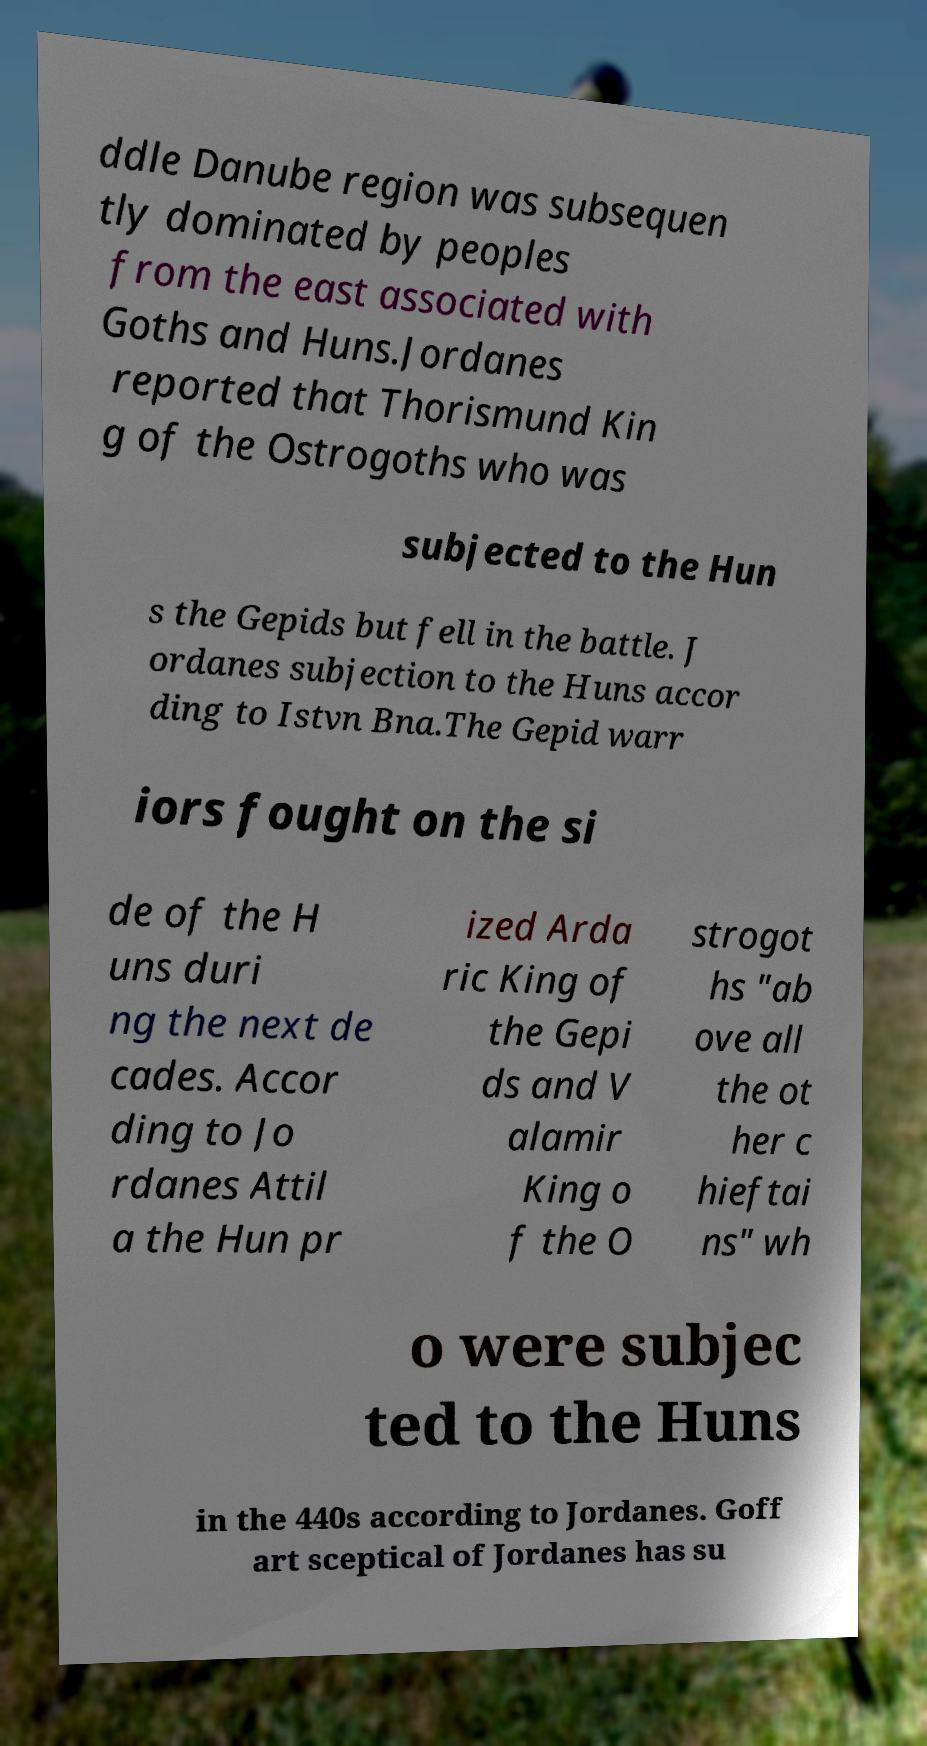Please read and relay the text visible in this image. What does it say? ddle Danube region was subsequen tly dominated by peoples from the east associated with Goths and Huns.Jordanes reported that Thorismund Kin g of the Ostrogoths who was subjected to the Hun s the Gepids but fell in the battle. J ordanes subjection to the Huns accor ding to Istvn Bna.The Gepid warr iors fought on the si de of the H uns duri ng the next de cades. Accor ding to Jo rdanes Attil a the Hun pr ized Arda ric King of the Gepi ds and V alamir King o f the O strogot hs "ab ove all the ot her c hieftai ns" wh o were subjec ted to the Huns in the 440s according to Jordanes. Goff art sceptical of Jordanes has su 